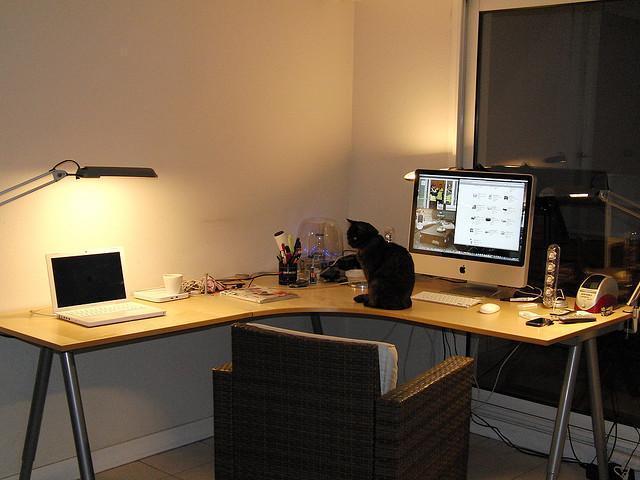How many computers are there?
Give a very brief answer. 2. 